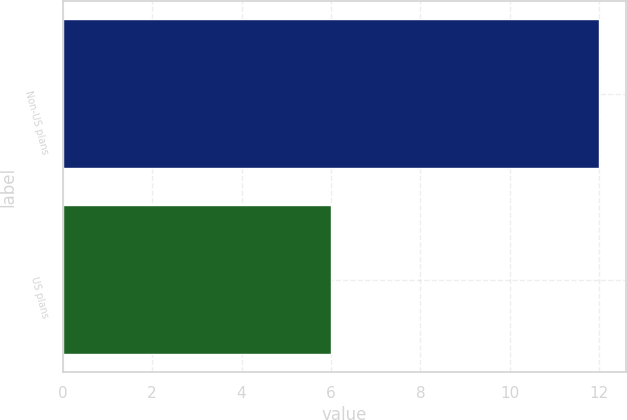Convert chart. <chart><loc_0><loc_0><loc_500><loc_500><bar_chart><fcel>Non-US plans<fcel>US plans<nl><fcel>12<fcel>6<nl></chart> 